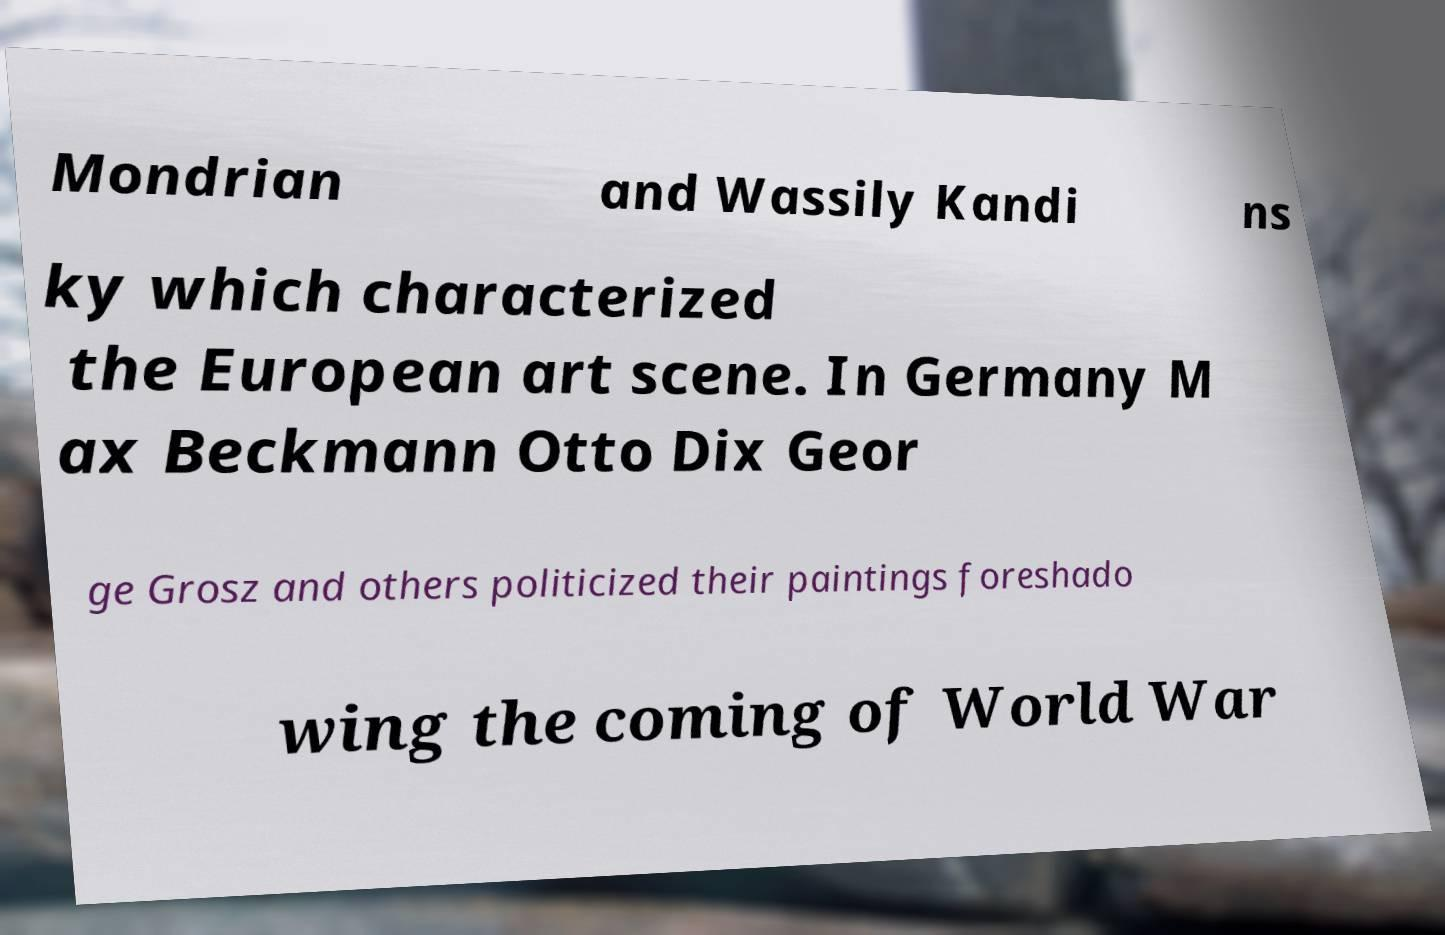Can you read and provide the text displayed in the image?This photo seems to have some interesting text. Can you extract and type it out for me? Mondrian and Wassily Kandi ns ky which characterized the European art scene. In Germany M ax Beckmann Otto Dix Geor ge Grosz and others politicized their paintings foreshado wing the coming of World War 